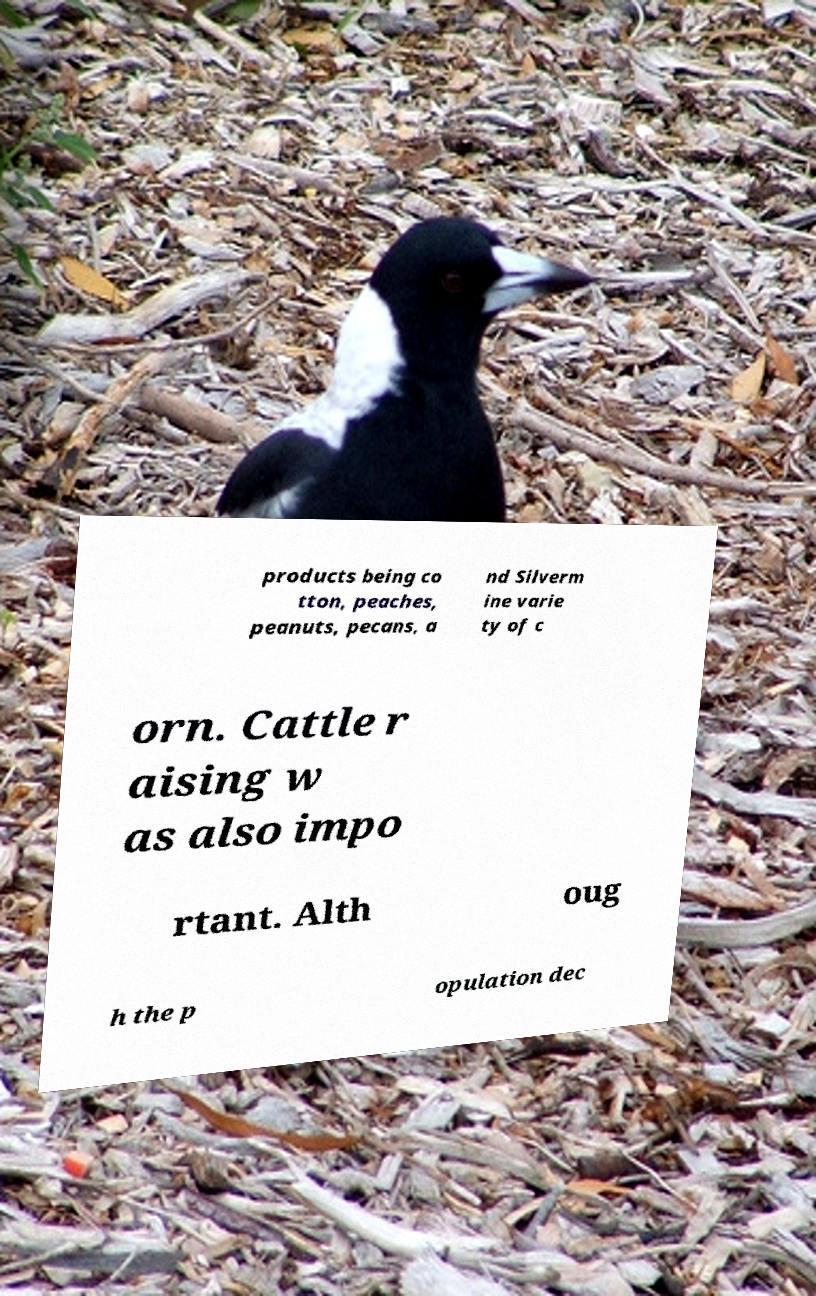Please identify and transcribe the text found in this image. products being co tton, peaches, peanuts, pecans, a nd Silverm ine varie ty of c orn. Cattle r aising w as also impo rtant. Alth oug h the p opulation dec 